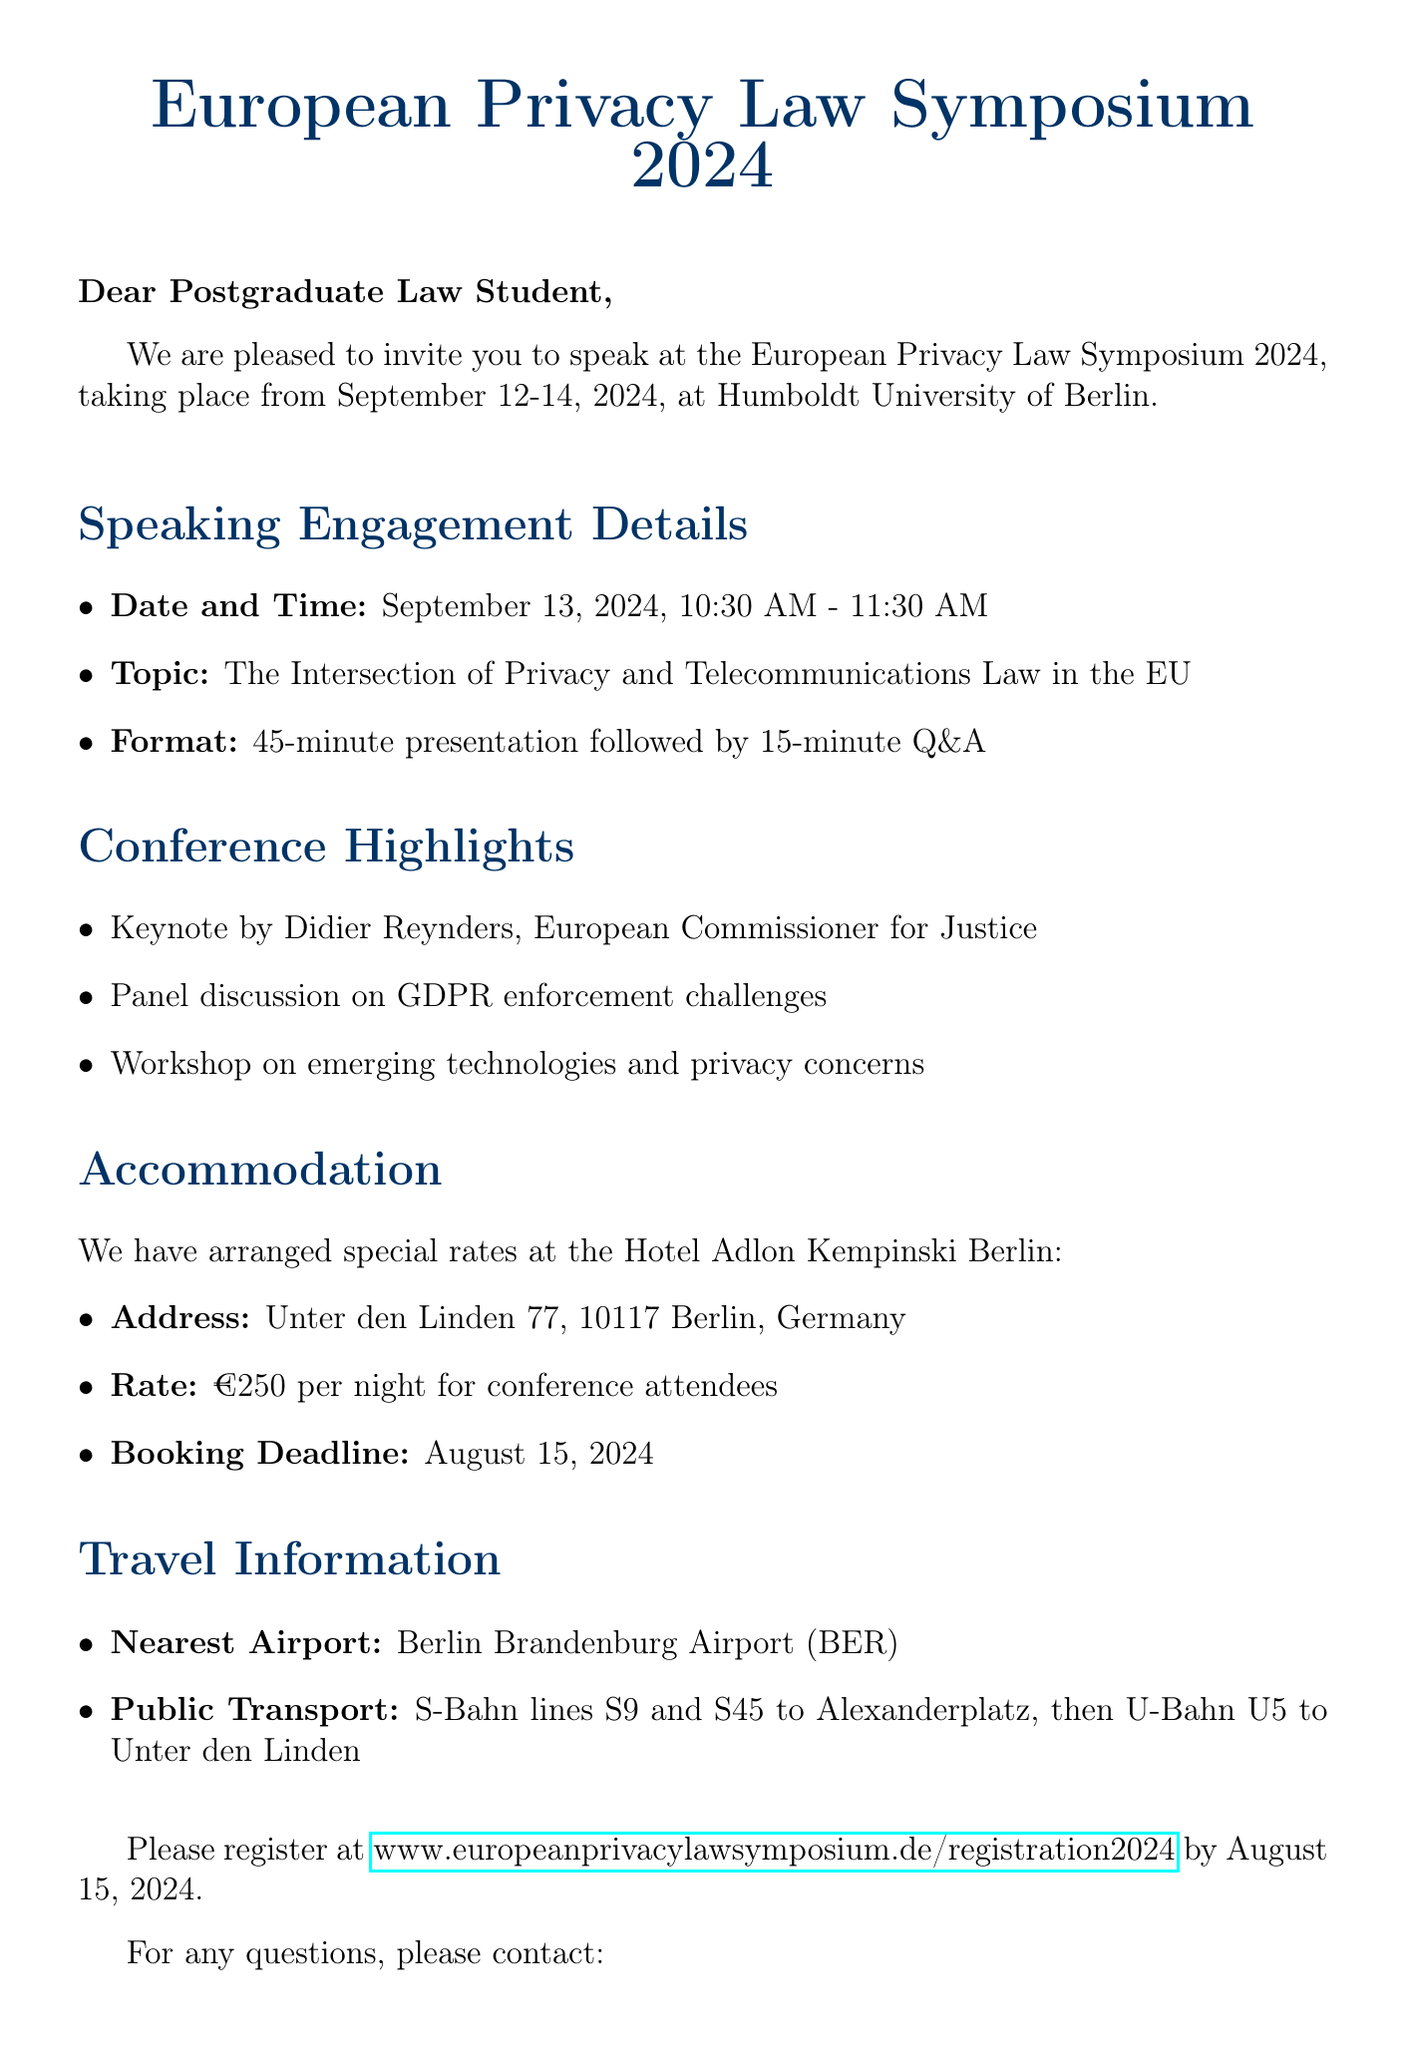What is the event name? The event name is explicitly stated at the beginning of the document.
Answer: European Privacy Law Symposium 2024 What are the event dates? The document clearly mentions the dates of the event in a concise format.
Answer: September 12-14, 2024 Who is the keynote speaker? The document lists the keynote speaker as part of the conference highlights.
Answer: Didier Reynders What is the address of the venue? The address is specified in the venue section of the document.
Answer: Unter den Linden 6, 10117 Berlin, Germany What is the special rate for accommodation per night? The accommodation section states a specific rate for conference attendees.
Answer: €250 When is the booking deadline for the hotel? The booking deadline is provided in the accommodation section of the document.
Answer: August 15, 2024 What is the format of the speaking engagement? The format is stated alongside the specific details of the speaker slot.
Answer: 45-minute presentation followed by 15-minute Q&A What is the nearest airport mentioned? The travel information section names the closest airport to the venue.
Answer: Berlin Brandenburg Airport (BER) What is the contact person's role? The role of the contact person is specified in the contact information section.
Answer: Conference Organizer 